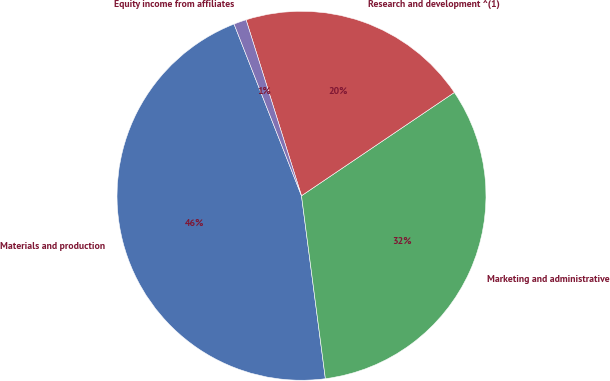Convert chart to OTSL. <chart><loc_0><loc_0><loc_500><loc_500><pie_chart><fcel>Materials and production<fcel>Marketing and administrative<fcel>Research and development ^(1)<fcel>Equity income from affiliates<nl><fcel>46.11%<fcel>32.39%<fcel>20.4%<fcel>1.1%<nl></chart> 